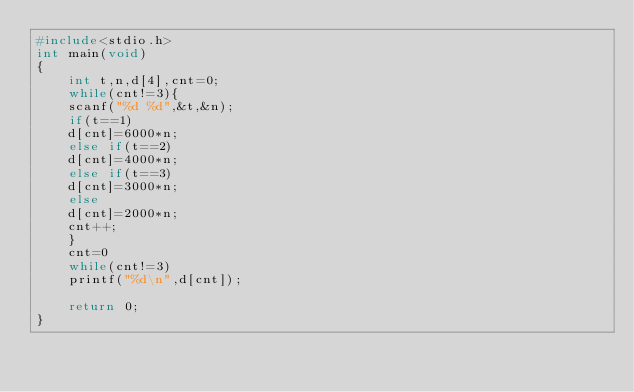Convert code to text. <code><loc_0><loc_0><loc_500><loc_500><_C_>#include<stdio.h>
int main(void)
{
	int t,n,d[4],cnt=0;
	while(cnt!=3){
	scanf("%d %d",&t,&n);
	if(t==1)
	d[cnt]=6000*n;
	else if(t==2)
	d[cnt]=4000*n;
	else if(t==3)
	d[cnt]=3000*n;
	else
	d[cnt]=2000*n;
	cnt++;
	}
	cnt=0
	while(cnt!=3)
	printf("%d\n",d[cnt]);

	return 0;
}</code> 